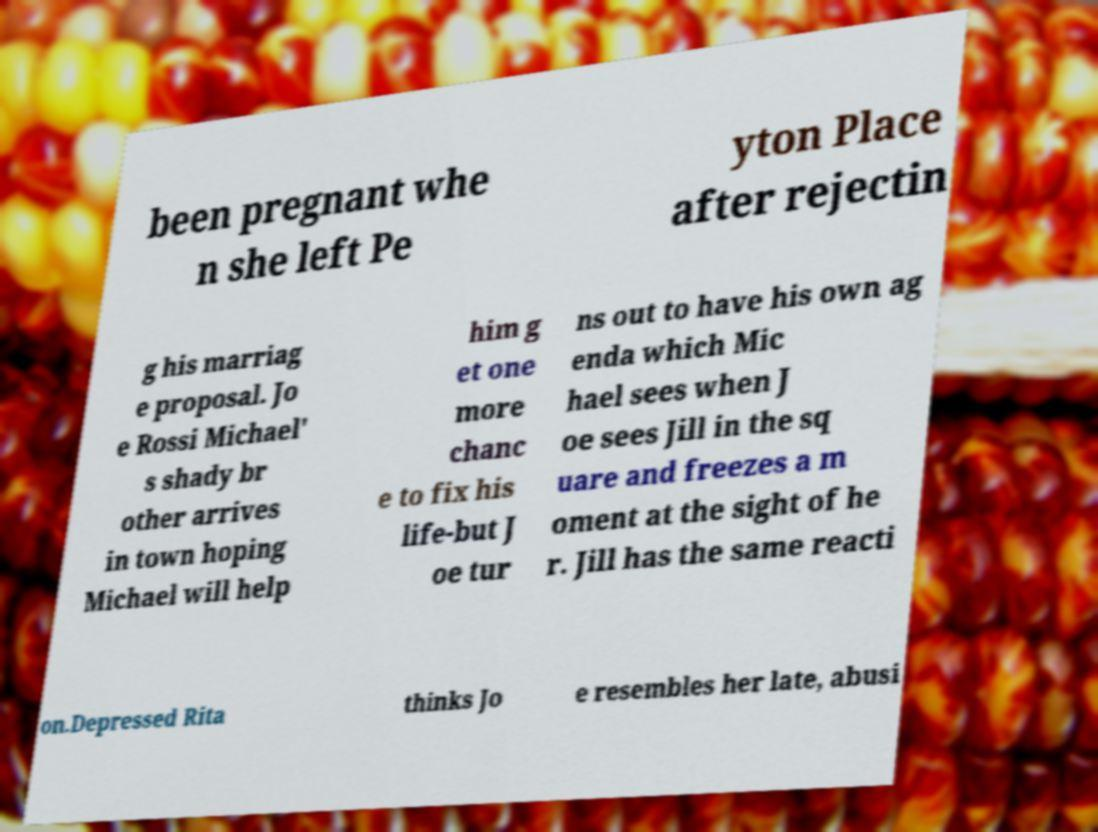I need the written content from this picture converted into text. Can you do that? been pregnant whe n she left Pe yton Place after rejectin g his marriag e proposal. Jo e Rossi Michael' s shady br other arrives in town hoping Michael will help him g et one more chanc e to fix his life-but J oe tur ns out to have his own ag enda which Mic hael sees when J oe sees Jill in the sq uare and freezes a m oment at the sight of he r. Jill has the same reacti on.Depressed Rita thinks Jo e resembles her late, abusi 